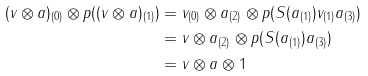Convert formula to latex. <formula><loc_0><loc_0><loc_500><loc_500>( v \otimes a ) _ { ( 0 ) } \otimes p ( ( v \otimes a ) _ { ( 1 ) } ) & = v _ { ( 0 ) } \otimes a _ { ( 2 ) } \otimes p ( S ( a _ { ( 1 ) } ) v _ { ( 1 ) } a _ { ( 3 ) } ) \\ & = v \otimes a _ { ( 2 ) } \otimes p ( S ( a _ { ( 1 ) } ) a _ { ( 3 ) } ) \\ & = v \otimes a \otimes 1</formula> 